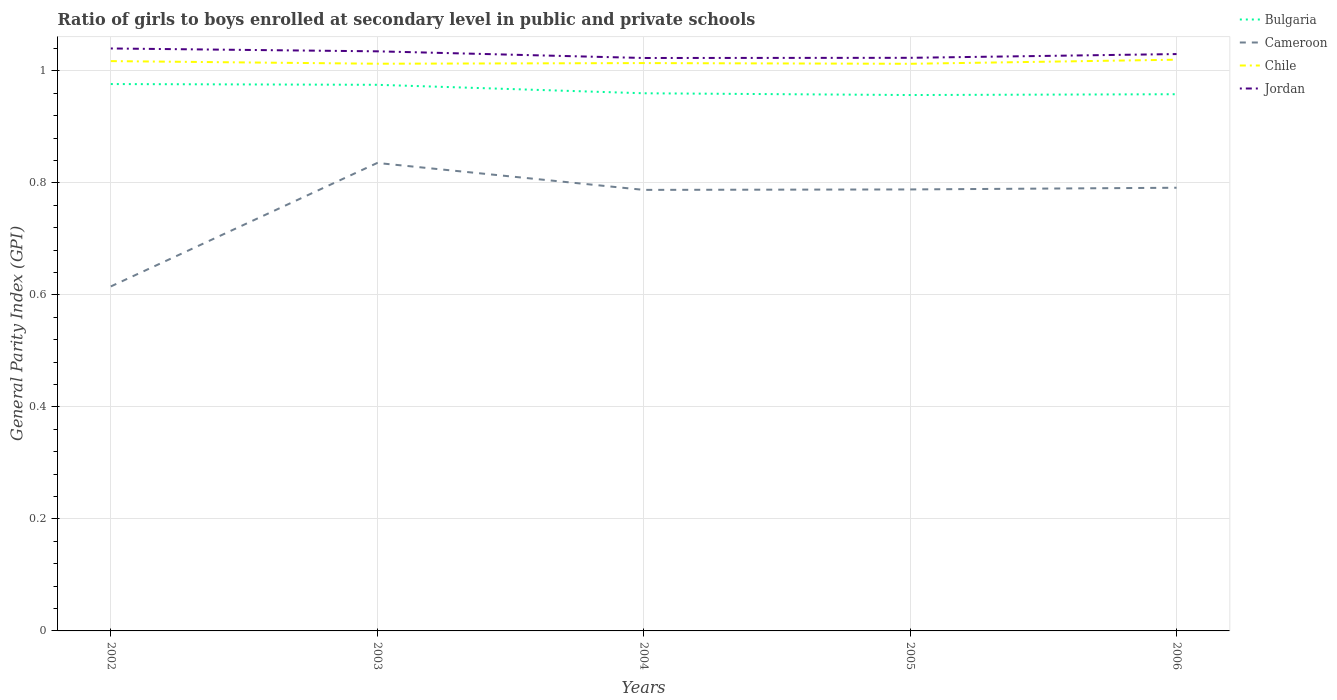Across all years, what is the maximum general parity index in Jordan?
Make the answer very short. 1.02. In which year was the general parity index in Bulgaria maximum?
Offer a very short reply. 2005. What is the total general parity index in Chile in the graph?
Provide a succinct answer. 0. What is the difference between the highest and the second highest general parity index in Cameroon?
Give a very brief answer. 0.22. Is the general parity index in Chile strictly greater than the general parity index in Jordan over the years?
Your answer should be compact. Yes. How many lines are there?
Provide a succinct answer. 4. How many years are there in the graph?
Provide a succinct answer. 5. Does the graph contain grids?
Make the answer very short. Yes. How many legend labels are there?
Make the answer very short. 4. What is the title of the graph?
Offer a terse response. Ratio of girls to boys enrolled at secondary level in public and private schools. What is the label or title of the X-axis?
Offer a very short reply. Years. What is the label or title of the Y-axis?
Your answer should be very brief. General Parity Index (GPI). What is the General Parity Index (GPI) of Bulgaria in 2002?
Provide a succinct answer. 0.98. What is the General Parity Index (GPI) in Cameroon in 2002?
Provide a short and direct response. 0.62. What is the General Parity Index (GPI) of Chile in 2002?
Make the answer very short. 1.02. What is the General Parity Index (GPI) in Jordan in 2002?
Your response must be concise. 1.04. What is the General Parity Index (GPI) in Bulgaria in 2003?
Your response must be concise. 0.98. What is the General Parity Index (GPI) in Cameroon in 2003?
Provide a succinct answer. 0.84. What is the General Parity Index (GPI) of Chile in 2003?
Your response must be concise. 1.01. What is the General Parity Index (GPI) in Jordan in 2003?
Provide a succinct answer. 1.03. What is the General Parity Index (GPI) in Bulgaria in 2004?
Your answer should be compact. 0.96. What is the General Parity Index (GPI) of Cameroon in 2004?
Make the answer very short. 0.79. What is the General Parity Index (GPI) in Chile in 2004?
Provide a short and direct response. 1.01. What is the General Parity Index (GPI) in Jordan in 2004?
Offer a very short reply. 1.02. What is the General Parity Index (GPI) in Bulgaria in 2005?
Offer a very short reply. 0.96. What is the General Parity Index (GPI) of Cameroon in 2005?
Keep it short and to the point. 0.79. What is the General Parity Index (GPI) of Chile in 2005?
Make the answer very short. 1.01. What is the General Parity Index (GPI) of Jordan in 2005?
Your answer should be compact. 1.02. What is the General Parity Index (GPI) of Bulgaria in 2006?
Provide a succinct answer. 0.96. What is the General Parity Index (GPI) in Cameroon in 2006?
Offer a very short reply. 0.79. What is the General Parity Index (GPI) of Chile in 2006?
Offer a very short reply. 1.02. What is the General Parity Index (GPI) in Jordan in 2006?
Your answer should be very brief. 1.03. Across all years, what is the maximum General Parity Index (GPI) of Bulgaria?
Offer a terse response. 0.98. Across all years, what is the maximum General Parity Index (GPI) of Cameroon?
Provide a succinct answer. 0.84. Across all years, what is the maximum General Parity Index (GPI) of Chile?
Provide a succinct answer. 1.02. Across all years, what is the maximum General Parity Index (GPI) in Jordan?
Provide a short and direct response. 1.04. Across all years, what is the minimum General Parity Index (GPI) of Bulgaria?
Offer a very short reply. 0.96. Across all years, what is the minimum General Parity Index (GPI) in Cameroon?
Keep it short and to the point. 0.62. Across all years, what is the minimum General Parity Index (GPI) of Chile?
Offer a terse response. 1.01. Across all years, what is the minimum General Parity Index (GPI) of Jordan?
Keep it short and to the point. 1.02. What is the total General Parity Index (GPI) of Bulgaria in the graph?
Offer a very short reply. 4.83. What is the total General Parity Index (GPI) of Cameroon in the graph?
Your answer should be compact. 3.82. What is the total General Parity Index (GPI) in Chile in the graph?
Make the answer very short. 5.08. What is the total General Parity Index (GPI) in Jordan in the graph?
Your answer should be compact. 5.15. What is the difference between the General Parity Index (GPI) in Bulgaria in 2002 and that in 2003?
Your answer should be compact. 0. What is the difference between the General Parity Index (GPI) of Cameroon in 2002 and that in 2003?
Offer a terse response. -0.22. What is the difference between the General Parity Index (GPI) of Chile in 2002 and that in 2003?
Provide a succinct answer. 0. What is the difference between the General Parity Index (GPI) of Jordan in 2002 and that in 2003?
Your answer should be very brief. 0.01. What is the difference between the General Parity Index (GPI) of Bulgaria in 2002 and that in 2004?
Keep it short and to the point. 0.02. What is the difference between the General Parity Index (GPI) in Cameroon in 2002 and that in 2004?
Make the answer very short. -0.17. What is the difference between the General Parity Index (GPI) in Chile in 2002 and that in 2004?
Give a very brief answer. 0. What is the difference between the General Parity Index (GPI) of Jordan in 2002 and that in 2004?
Give a very brief answer. 0.02. What is the difference between the General Parity Index (GPI) of Bulgaria in 2002 and that in 2005?
Your response must be concise. 0.02. What is the difference between the General Parity Index (GPI) in Cameroon in 2002 and that in 2005?
Your answer should be compact. -0.17. What is the difference between the General Parity Index (GPI) of Chile in 2002 and that in 2005?
Make the answer very short. 0. What is the difference between the General Parity Index (GPI) in Jordan in 2002 and that in 2005?
Give a very brief answer. 0.02. What is the difference between the General Parity Index (GPI) of Bulgaria in 2002 and that in 2006?
Give a very brief answer. 0.02. What is the difference between the General Parity Index (GPI) in Cameroon in 2002 and that in 2006?
Ensure brevity in your answer.  -0.18. What is the difference between the General Parity Index (GPI) of Chile in 2002 and that in 2006?
Give a very brief answer. -0. What is the difference between the General Parity Index (GPI) in Bulgaria in 2003 and that in 2004?
Make the answer very short. 0.02. What is the difference between the General Parity Index (GPI) in Cameroon in 2003 and that in 2004?
Provide a succinct answer. 0.05. What is the difference between the General Parity Index (GPI) in Chile in 2003 and that in 2004?
Make the answer very short. -0. What is the difference between the General Parity Index (GPI) in Jordan in 2003 and that in 2004?
Make the answer very short. 0.01. What is the difference between the General Parity Index (GPI) of Bulgaria in 2003 and that in 2005?
Offer a very short reply. 0.02. What is the difference between the General Parity Index (GPI) of Cameroon in 2003 and that in 2005?
Provide a succinct answer. 0.05. What is the difference between the General Parity Index (GPI) in Chile in 2003 and that in 2005?
Keep it short and to the point. 0. What is the difference between the General Parity Index (GPI) of Jordan in 2003 and that in 2005?
Offer a very short reply. 0.01. What is the difference between the General Parity Index (GPI) in Bulgaria in 2003 and that in 2006?
Your answer should be compact. 0.02. What is the difference between the General Parity Index (GPI) of Cameroon in 2003 and that in 2006?
Keep it short and to the point. 0.04. What is the difference between the General Parity Index (GPI) of Chile in 2003 and that in 2006?
Your answer should be compact. -0.01. What is the difference between the General Parity Index (GPI) in Jordan in 2003 and that in 2006?
Give a very brief answer. 0. What is the difference between the General Parity Index (GPI) of Bulgaria in 2004 and that in 2005?
Keep it short and to the point. 0. What is the difference between the General Parity Index (GPI) in Cameroon in 2004 and that in 2005?
Keep it short and to the point. -0. What is the difference between the General Parity Index (GPI) of Chile in 2004 and that in 2005?
Provide a succinct answer. 0. What is the difference between the General Parity Index (GPI) of Jordan in 2004 and that in 2005?
Provide a short and direct response. -0. What is the difference between the General Parity Index (GPI) of Bulgaria in 2004 and that in 2006?
Make the answer very short. 0. What is the difference between the General Parity Index (GPI) in Cameroon in 2004 and that in 2006?
Provide a short and direct response. -0. What is the difference between the General Parity Index (GPI) of Chile in 2004 and that in 2006?
Offer a terse response. -0.01. What is the difference between the General Parity Index (GPI) in Jordan in 2004 and that in 2006?
Give a very brief answer. -0.01. What is the difference between the General Parity Index (GPI) of Bulgaria in 2005 and that in 2006?
Your answer should be compact. -0. What is the difference between the General Parity Index (GPI) of Cameroon in 2005 and that in 2006?
Make the answer very short. -0. What is the difference between the General Parity Index (GPI) in Chile in 2005 and that in 2006?
Your answer should be very brief. -0.01. What is the difference between the General Parity Index (GPI) in Jordan in 2005 and that in 2006?
Provide a succinct answer. -0.01. What is the difference between the General Parity Index (GPI) of Bulgaria in 2002 and the General Parity Index (GPI) of Cameroon in 2003?
Offer a very short reply. 0.14. What is the difference between the General Parity Index (GPI) in Bulgaria in 2002 and the General Parity Index (GPI) in Chile in 2003?
Give a very brief answer. -0.04. What is the difference between the General Parity Index (GPI) in Bulgaria in 2002 and the General Parity Index (GPI) in Jordan in 2003?
Provide a succinct answer. -0.06. What is the difference between the General Parity Index (GPI) in Cameroon in 2002 and the General Parity Index (GPI) in Chile in 2003?
Provide a succinct answer. -0.4. What is the difference between the General Parity Index (GPI) of Cameroon in 2002 and the General Parity Index (GPI) of Jordan in 2003?
Provide a succinct answer. -0.42. What is the difference between the General Parity Index (GPI) in Chile in 2002 and the General Parity Index (GPI) in Jordan in 2003?
Give a very brief answer. -0.02. What is the difference between the General Parity Index (GPI) in Bulgaria in 2002 and the General Parity Index (GPI) in Cameroon in 2004?
Give a very brief answer. 0.19. What is the difference between the General Parity Index (GPI) of Bulgaria in 2002 and the General Parity Index (GPI) of Chile in 2004?
Give a very brief answer. -0.04. What is the difference between the General Parity Index (GPI) in Bulgaria in 2002 and the General Parity Index (GPI) in Jordan in 2004?
Give a very brief answer. -0.05. What is the difference between the General Parity Index (GPI) in Cameroon in 2002 and the General Parity Index (GPI) in Chile in 2004?
Make the answer very short. -0.4. What is the difference between the General Parity Index (GPI) in Cameroon in 2002 and the General Parity Index (GPI) in Jordan in 2004?
Your response must be concise. -0.41. What is the difference between the General Parity Index (GPI) in Chile in 2002 and the General Parity Index (GPI) in Jordan in 2004?
Provide a succinct answer. -0.01. What is the difference between the General Parity Index (GPI) of Bulgaria in 2002 and the General Parity Index (GPI) of Cameroon in 2005?
Your answer should be very brief. 0.19. What is the difference between the General Parity Index (GPI) of Bulgaria in 2002 and the General Parity Index (GPI) of Chile in 2005?
Keep it short and to the point. -0.04. What is the difference between the General Parity Index (GPI) of Bulgaria in 2002 and the General Parity Index (GPI) of Jordan in 2005?
Offer a very short reply. -0.05. What is the difference between the General Parity Index (GPI) in Cameroon in 2002 and the General Parity Index (GPI) in Chile in 2005?
Give a very brief answer. -0.4. What is the difference between the General Parity Index (GPI) of Cameroon in 2002 and the General Parity Index (GPI) of Jordan in 2005?
Ensure brevity in your answer.  -0.41. What is the difference between the General Parity Index (GPI) in Chile in 2002 and the General Parity Index (GPI) in Jordan in 2005?
Your answer should be very brief. -0.01. What is the difference between the General Parity Index (GPI) in Bulgaria in 2002 and the General Parity Index (GPI) in Cameroon in 2006?
Make the answer very short. 0.19. What is the difference between the General Parity Index (GPI) in Bulgaria in 2002 and the General Parity Index (GPI) in Chile in 2006?
Provide a short and direct response. -0.04. What is the difference between the General Parity Index (GPI) of Bulgaria in 2002 and the General Parity Index (GPI) of Jordan in 2006?
Give a very brief answer. -0.05. What is the difference between the General Parity Index (GPI) in Cameroon in 2002 and the General Parity Index (GPI) in Chile in 2006?
Your answer should be compact. -0.4. What is the difference between the General Parity Index (GPI) of Cameroon in 2002 and the General Parity Index (GPI) of Jordan in 2006?
Provide a succinct answer. -0.41. What is the difference between the General Parity Index (GPI) in Chile in 2002 and the General Parity Index (GPI) in Jordan in 2006?
Offer a very short reply. -0.01. What is the difference between the General Parity Index (GPI) of Bulgaria in 2003 and the General Parity Index (GPI) of Cameroon in 2004?
Your answer should be very brief. 0.19. What is the difference between the General Parity Index (GPI) of Bulgaria in 2003 and the General Parity Index (GPI) of Chile in 2004?
Your answer should be compact. -0.04. What is the difference between the General Parity Index (GPI) of Bulgaria in 2003 and the General Parity Index (GPI) of Jordan in 2004?
Your answer should be very brief. -0.05. What is the difference between the General Parity Index (GPI) of Cameroon in 2003 and the General Parity Index (GPI) of Chile in 2004?
Your answer should be very brief. -0.18. What is the difference between the General Parity Index (GPI) of Cameroon in 2003 and the General Parity Index (GPI) of Jordan in 2004?
Keep it short and to the point. -0.19. What is the difference between the General Parity Index (GPI) in Chile in 2003 and the General Parity Index (GPI) in Jordan in 2004?
Your answer should be compact. -0.01. What is the difference between the General Parity Index (GPI) of Bulgaria in 2003 and the General Parity Index (GPI) of Cameroon in 2005?
Your answer should be compact. 0.19. What is the difference between the General Parity Index (GPI) in Bulgaria in 2003 and the General Parity Index (GPI) in Chile in 2005?
Offer a very short reply. -0.04. What is the difference between the General Parity Index (GPI) of Bulgaria in 2003 and the General Parity Index (GPI) of Jordan in 2005?
Your answer should be very brief. -0.05. What is the difference between the General Parity Index (GPI) of Cameroon in 2003 and the General Parity Index (GPI) of Chile in 2005?
Provide a succinct answer. -0.18. What is the difference between the General Parity Index (GPI) of Cameroon in 2003 and the General Parity Index (GPI) of Jordan in 2005?
Provide a succinct answer. -0.19. What is the difference between the General Parity Index (GPI) in Chile in 2003 and the General Parity Index (GPI) in Jordan in 2005?
Provide a short and direct response. -0.01. What is the difference between the General Parity Index (GPI) in Bulgaria in 2003 and the General Parity Index (GPI) in Cameroon in 2006?
Offer a very short reply. 0.18. What is the difference between the General Parity Index (GPI) in Bulgaria in 2003 and the General Parity Index (GPI) in Chile in 2006?
Your response must be concise. -0.04. What is the difference between the General Parity Index (GPI) of Bulgaria in 2003 and the General Parity Index (GPI) of Jordan in 2006?
Your answer should be very brief. -0.05. What is the difference between the General Parity Index (GPI) in Cameroon in 2003 and the General Parity Index (GPI) in Chile in 2006?
Keep it short and to the point. -0.18. What is the difference between the General Parity Index (GPI) of Cameroon in 2003 and the General Parity Index (GPI) of Jordan in 2006?
Make the answer very short. -0.19. What is the difference between the General Parity Index (GPI) of Chile in 2003 and the General Parity Index (GPI) of Jordan in 2006?
Make the answer very short. -0.02. What is the difference between the General Parity Index (GPI) in Bulgaria in 2004 and the General Parity Index (GPI) in Cameroon in 2005?
Give a very brief answer. 0.17. What is the difference between the General Parity Index (GPI) of Bulgaria in 2004 and the General Parity Index (GPI) of Chile in 2005?
Your response must be concise. -0.05. What is the difference between the General Parity Index (GPI) of Bulgaria in 2004 and the General Parity Index (GPI) of Jordan in 2005?
Keep it short and to the point. -0.06. What is the difference between the General Parity Index (GPI) in Cameroon in 2004 and the General Parity Index (GPI) in Chile in 2005?
Keep it short and to the point. -0.23. What is the difference between the General Parity Index (GPI) in Cameroon in 2004 and the General Parity Index (GPI) in Jordan in 2005?
Give a very brief answer. -0.24. What is the difference between the General Parity Index (GPI) of Chile in 2004 and the General Parity Index (GPI) of Jordan in 2005?
Make the answer very short. -0.01. What is the difference between the General Parity Index (GPI) of Bulgaria in 2004 and the General Parity Index (GPI) of Cameroon in 2006?
Your answer should be compact. 0.17. What is the difference between the General Parity Index (GPI) of Bulgaria in 2004 and the General Parity Index (GPI) of Chile in 2006?
Keep it short and to the point. -0.06. What is the difference between the General Parity Index (GPI) in Bulgaria in 2004 and the General Parity Index (GPI) in Jordan in 2006?
Keep it short and to the point. -0.07. What is the difference between the General Parity Index (GPI) in Cameroon in 2004 and the General Parity Index (GPI) in Chile in 2006?
Ensure brevity in your answer.  -0.23. What is the difference between the General Parity Index (GPI) of Cameroon in 2004 and the General Parity Index (GPI) of Jordan in 2006?
Offer a very short reply. -0.24. What is the difference between the General Parity Index (GPI) in Chile in 2004 and the General Parity Index (GPI) in Jordan in 2006?
Your answer should be very brief. -0.02. What is the difference between the General Parity Index (GPI) of Bulgaria in 2005 and the General Parity Index (GPI) of Cameroon in 2006?
Ensure brevity in your answer.  0.17. What is the difference between the General Parity Index (GPI) in Bulgaria in 2005 and the General Parity Index (GPI) in Chile in 2006?
Provide a short and direct response. -0.06. What is the difference between the General Parity Index (GPI) in Bulgaria in 2005 and the General Parity Index (GPI) in Jordan in 2006?
Offer a terse response. -0.07. What is the difference between the General Parity Index (GPI) in Cameroon in 2005 and the General Parity Index (GPI) in Chile in 2006?
Your response must be concise. -0.23. What is the difference between the General Parity Index (GPI) of Cameroon in 2005 and the General Parity Index (GPI) of Jordan in 2006?
Make the answer very short. -0.24. What is the difference between the General Parity Index (GPI) in Chile in 2005 and the General Parity Index (GPI) in Jordan in 2006?
Make the answer very short. -0.02. What is the average General Parity Index (GPI) in Bulgaria per year?
Keep it short and to the point. 0.97. What is the average General Parity Index (GPI) of Cameroon per year?
Keep it short and to the point. 0.76. What is the average General Parity Index (GPI) in Chile per year?
Give a very brief answer. 1.02. What is the average General Parity Index (GPI) of Jordan per year?
Make the answer very short. 1.03. In the year 2002, what is the difference between the General Parity Index (GPI) of Bulgaria and General Parity Index (GPI) of Cameroon?
Provide a succinct answer. 0.36. In the year 2002, what is the difference between the General Parity Index (GPI) of Bulgaria and General Parity Index (GPI) of Chile?
Provide a succinct answer. -0.04. In the year 2002, what is the difference between the General Parity Index (GPI) in Bulgaria and General Parity Index (GPI) in Jordan?
Offer a very short reply. -0.06. In the year 2002, what is the difference between the General Parity Index (GPI) of Cameroon and General Parity Index (GPI) of Chile?
Your answer should be compact. -0.4. In the year 2002, what is the difference between the General Parity Index (GPI) of Cameroon and General Parity Index (GPI) of Jordan?
Offer a very short reply. -0.42. In the year 2002, what is the difference between the General Parity Index (GPI) in Chile and General Parity Index (GPI) in Jordan?
Make the answer very short. -0.02. In the year 2003, what is the difference between the General Parity Index (GPI) in Bulgaria and General Parity Index (GPI) in Cameroon?
Ensure brevity in your answer.  0.14. In the year 2003, what is the difference between the General Parity Index (GPI) of Bulgaria and General Parity Index (GPI) of Chile?
Ensure brevity in your answer.  -0.04. In the year 2003, what is the difference between the General Parity Index (GPI) in Bulgaria and General Parity Index (GPI) in Jordan?
Give a very brief answer. -0.06. In the year 2003, what is the difference between the General Parity Index (GPI) of Cameroon and General Parity Index (GPI) of Chile?
Give a very brief answer. -0.18. In the year 2003, what is the difference between the General Parity Index (GPI) in Cameroon and General Parity Index (GPI) in Jordan?
Offer a very short reply. -0.2. In the year 2003, what is the difference between the General Parity Index (GPI) of Chile and General Parity Index (GPI) of Jordan?
Your answer should be compact. -0.02. In the year 2004, what is the difference between the General Parity Index (GPI) of Bulgaria and General Parity Index (GPI) of Cameroon?
Keep it short and to the point. 0.17. In the year 2004, what is the difference between the General Parity Index (GPI) in Bulgaria and General Parity Index (GPI) in Chile?
Ensure brevity in your answer.  -0.05. In the year 2004, what is the difference between the General Parity Index (GPI) of Bulgaria and General Parity Index (GPI) of Jordan?
Keep it short and to the point. -0.06. In the year 2004, what is the difference between the General Parity Index (GPI) in Cameroon and General Parity Index (GPI) in Chile?
Give a very brief answer. -0.23. In the year 2004, what is the difference between the General Parity Index (GPI) in Cameroon and General Parity Index (GPI) in Jordan?
Your response must be concise. -0.24. In the year 2004, what is the difference between the General Parity Index (GPI) in Chile and General Parity Index (GPI) in Jordan?
Provide a succinct answer. -0.01. In the year 2005, what is the difference between the General Parity Index (GPI) in Bulgaria and General Parity Index (GPI) in Cameroon?
Your answer should be compact. 0.17. In the year 2005, what is the difference between the General Parity Index (GPI) in Bulgaria and General Parity Index (GPI) in Chile?
Ensure brevity in your answer.  -0.06. In the year 2005, what is the difference between the General Parity Index (GPI) of Bulgaria and General Parity Index (GPI) of Jordan?
Make the answer very short. -0.07. In the year 2005, what is the difference between the General Parity Index (GPI) in Cameroon and General Parity Index (GPI) in Chile?
Provide a succinct answer. -0.22. In the year 2005, what is the difference between the General Parity Index (GPI) of Cameroon and General Parity Index (GPI) of Jordan?
Give a very brief answer. -0.23. In the year 2005, what is the difference between the General Parity Index (GPI) in Chile and General Parity Index (GPI) in Jordan?
Offer a very short reply. -0.01. In the year 2006, what is the difference between the General Parity Index (GPI) of Bulgaria and General Parity Index (GPI) of Cameroon?
Give a very brief answer. 0.17. In the year 2006, what is the difference between the General Parity Index (GPI) of Bulgaria and General Parity Index (GPI) of Chile?
Provide a succinct answer. -0.06. In the year 2006, what is the difference between the General Parity Index (GPI) in Bulgaria and General Parity Index (GPI) in Jordan?
Provide a short and direct response. -0.07. In the year 2006, what is the difference between the General Parity Index (GPI) in Cameroon and General Parity Index (GPI) in Chile?
Your response must be concise. -0.23. In the year 2006, what is the difference between the General Parity Index (GPI) of Cameroon and General Parity Index (GPI) of Jordan?
Your answer should be very brief. -0.24. In the year 2006, what is the difference between the General Parity Index (GPI) of Chile and General Parity Index (GPI) of Jordan?
Give a very brief answer. -0.01. What is the ratio of the General Parity Index (GPI) in Cameroon in 2002 to that in 2003?
Provide a short and direct response. 0.74. What is the ratio of the General Parity Index (GPI) in Chile in 2002 to that in 2003?
Offer a terse response. 1. What is the ratio of the General Parity Index (GPI) in Bulgaria in 2002 to that in 2004?
Provide a succinct answer. 1.02. What is the ratio of the General Parity Index (GPI) in Cameroon in 2002 to that in 2004?
Offer a terse response. 0.78. What is the ratio of the General Parity Index (GPI) of Chile in 2002 to that in 2004?
Offer a very short reply. 1. What is the ratio of the General Parity Index (GPI) of Jordan in 2002 to that in 2004?
Your response must be concise. 1.02. What is the ratio of the General Parity Index (GPI) of Bulgaria in 2002 to that in 2005?
Your answer should be compact. 1.02. What is the ratio of the General Parity Index (GPI) in Cameroon in 2002 to that in 2005?
Offer a very short reply. 0.78. What is the ratio of the General Parity Index (GPI) of Jordan in 2002 to that in 2005?
Offer a terse response. 1.02. What is the ratio of the General Parity Index (GPI) of Bulgaria in 2002 to that in 2006?
Your answer should be compact. 1.02. What is the ratio of the General Parity Index (GPI) in Cameroon in 2002 to that in 2006?
Offer a very short reply. 0.78. What is the ratio of the General Parity Index (GPI) in Chile in 2002 to that in 2006?
Your response must be concise. 1. What is the ratio of the General Parity Index (GPI) in Jordan in 2002 to that in 2006?
Offer a very short reply. 1.01. What is the ratio of the General Parity Index (GPI) of Bulgaria in 2003 to that in 2004?
Ensure brevity in your answer.  1.02. What is the ratio of the General Parity Index (GPI) of Cameroon in 2003 to that in 2004?
Your answer should be very brief. 1.06. What is the ratio of the General Parity Index (GPI) in Chile in 2003 to that in 2004?
Offer a very short reply. 1. What is the ratio of the General Parity Index (GPI) in Jordan in 2003 to that in 2004?
Your answer should be very brief. 1.01. What is the ratio of the General Parity Index (GPI) of Bulgaria in 2003 to that in 2005?
Your response must be concise. 1.02. What is the ratio of the General Parity Index (GPI) in Cameroon in 2003 to that in 2005?
Provide a short and direct response. 1.06. What is the ratio of the General Parity Index (GPI) in Chile in 2003 to that in 2005?
Your answer should be very brief. 1. What is the ratio of the General Parity Index (GPI) in Jordan in 2003 to that in 2005?
Your answer should be compact. 1.01. What is the ratio of the General Parity Index (GPI) in Bulgaria in 2003 to that in 2006?
Make the answer very short. 1.02. What is the ratio of the General Parity Index (GPI) of Cameroon in 2003 to that in 2006?
Your response must be concise. 1.06. What is the ratio of the General Parity Index (GPI) of Chile in 2003 to that in 2006?
Keep it short and to the point. 0.99. What is the ratio of the General Parity Index (GPI) of Jordan in 2003 to that in 2006?
Provide a succinct answer. 1. What is the ratio of the General Parity Index (GPI) of Cameroon in 2004 to that in 2005?
Ensure brevity in your answer.  1. What is the ratio of the General Parity Index (GPI) of Chile in 2004 to that in 2005?
Provide a short and direct response. 1. What is the ratio of the General Parity Index (GPI) of Jordan in 2004 to that in 2005?
Give a very brief answer. 1. What is the ratio of the General Parity Index (GPI) of Bulgaria in 2004 to that in 2006?
Ensure brevity in your answer.  1. What is the ratio of the General Parity Index (GPI) of Cameroon in 2004 to that in 2006?
Make the answer very short. 1. What is the ratio of the General Parity Index (GPI) in Chile in 2004 to that in 2006?
Provide a short and direct response. 0.99. What is the ratio of the General Parity Index (GPI) of Jordan in 2004 to that in 2006?
Provide a short and direct response. 0.99. What is the ratio of the General Parity Index (GPI) in Bulgaria in 2005 to that in 2006?
Your response must be concise. 1. What is the ratio of the General Parity Index (GPI) in Chile in 2005 to that in 2006?
Provide a succinct answer. 0.99. What is the ratio of the General Parity Index (GPI) of Jordan in 2005 to that in 2006?
Offer a terse response. 0.99. What is the difference between the highest and the second highest General Parity Index (GPI) of Bulgaria?
Your answer should be compact. 0. What is the difference between the highest and the second highest General Parity Index (GPI) in Cameroon?
Offer a very short reply. 0.04. What is the difference between the highest and the second highest General Parity Index (GPI) of Chile?
Your answer should be very brief. 0. What is the difference between the highest and the second highest General Parity Index (GPI) of Jordan?
Your response must be concise. 0.01. What is the difference between the highest and the lowest General Parity Index (GPI) in Bulgaria?
Provide a succinct answer. 0.02. What is the difference between the highest and the lowest General Parity Index (GPI) in Cameroon?
Give a very brief answer. 0.22. What is the difference between the highest and the lowest General Parity Index (GPI) of Chile?
Your answer should be compact. 0.01. What is the difference between the highest and the lowest General Parity Index (GPI) in Jordan?
Your answer should be very brief. 0.02. 